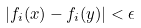Convert formula to latex. <formula><loc_0><loc_0><loc_500><loc_500>| f _ { i } ( x ) - f _ { i } ( y ) | < \epsilon</formula> 